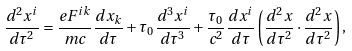<formula> <loc_0><loc_0><loc_500><loc_500>\frac { d ^ { 2 } x ^ { i } } { d \tau ^ { 2 } } = \frac { e F ^ { i k } } { m c } \frac { d x _ { k } } { d \tau } + \tau _ { 0 } \frac { d ^ { 3 } x ^ { i } } { d \tau ^ { 3 } } + \frac { \tau _ { 0 } } { c ^ { 2 } } \frac { d x ^ { i } } { d \tau } \left ( \frac { d ^ { 2 } x } { d \tau ^ { 2 } } \cdot \frac { d ^ { 2 } x } { d \tau ^ { 2 } } \right ) ,</formula> 